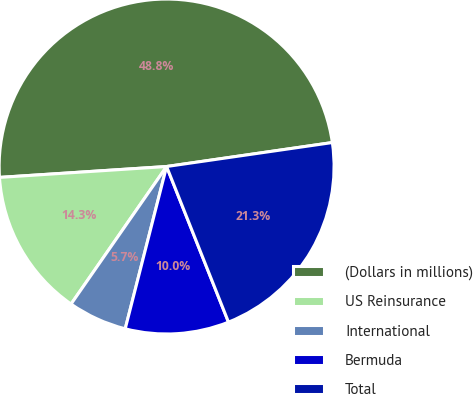Convert chart. <chart><loc_0><loc_0><loc_500><loc_500><pie_chart><fcel>(Dollars in millions)<fcel>US Reinsurance<fcel>International<fcel>Bermuda<fcel>Total<nl><fcel>48.75%<fcel>14.3%<fcel>5.69%<fcel>10.0%<fcel>21.26%<nl></chart> 